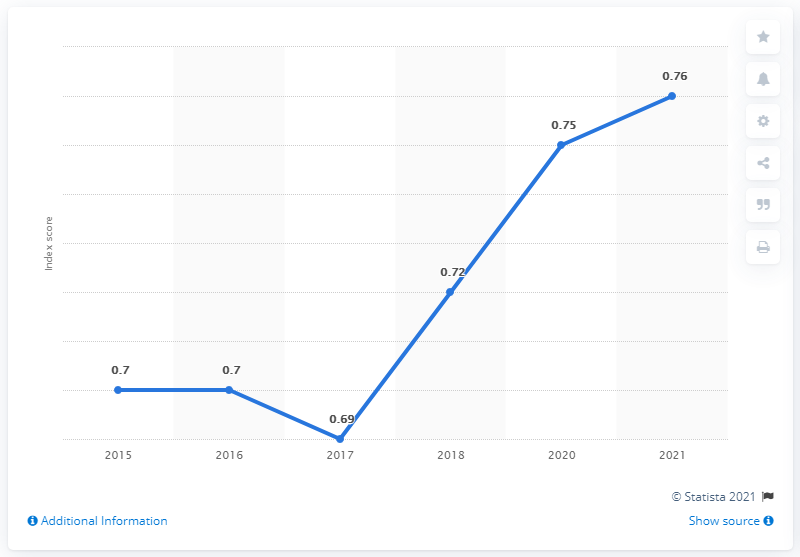Highlight a few significant elements in this photo. Since 2017, Mexico's score has been continuously increasing. 